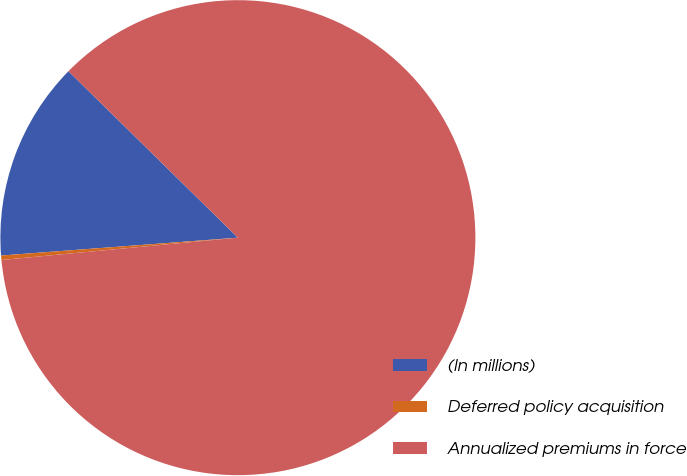Convert chart to OTSL. <chart><loc_0><loc_0><loc_500><loc_500><pie_chart><fcel>(In millions)<fcel>Deferred policy acquisition<fcel>Annualized premiums in force<nl><fcel>13.56%<fcel>0.3%<fcel>86.15%<nl></chart> 